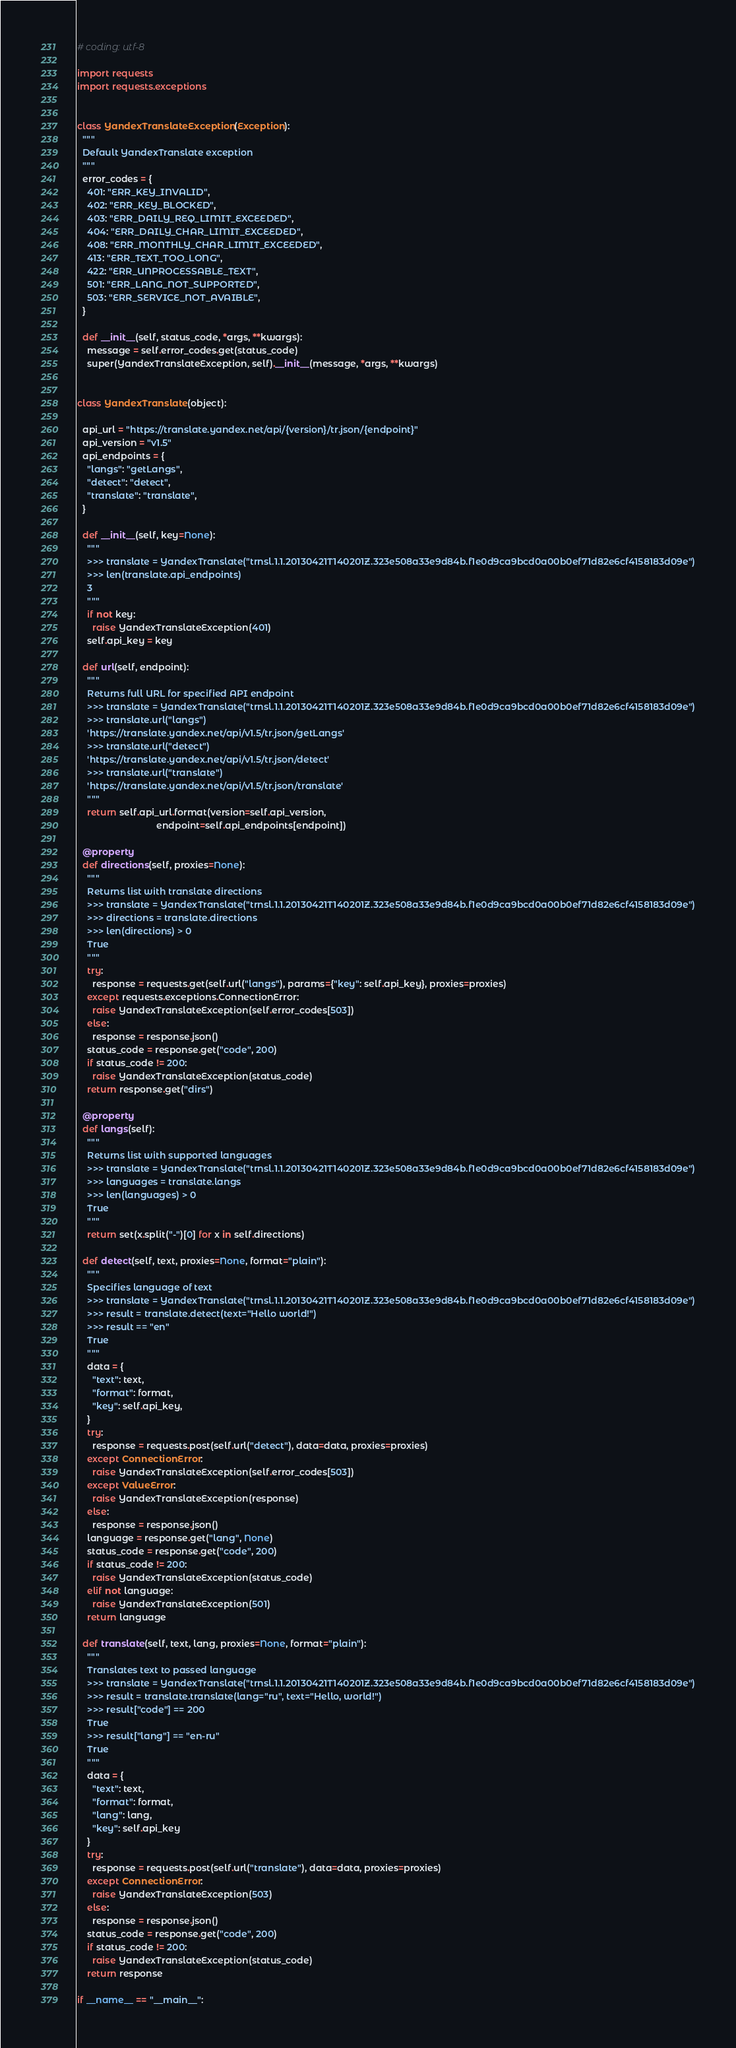<code> <loc_0><loc_0><loc_500><loc_500><_Python_># coding: utf-8

import requests
import requests.exceptions


class YandexTranslateException(Exception):
  """
  Default YandexTranslate exception
  """
  error_codes = {
    401: "ERR_KEY_INVALID",
    402: "ERR_KEY_BLOCKED",
    403: "ERR_DAILY_REQ_LIMIT_EXCEEDED",
    404: "ERR_DAILY_CHAR_LIMIT_EXCEEDED",
    408: "ERR_MONTHLY_CHAR_LIMIT_EXCEEDED",
    413: "ERR_TEXT_TOO_LONG",
    422: "ERR_UNPROCESSABLE_TEXT",
    501: "ERR_LANG_NOT_SUPPORTED",
    503: "ERR_SERVICE_NOT_AVAIBLE",
  }

  def __init__(self, status_code, *args, **kwargs):
    message = self.error_codes.get(status_code)
    super(YandexTranslateException, self).__init__(message, *args, **kwargs)


class YandexTranslate(object):

  api_url = "https://translate.yandex.net/api/{version}/tr.json/{endpoint}"
  api_version = "v1.5"
  api_endpoints = {
    "langs": "getLangs",
    "detect": "detect",
    "translate": "translate",
  }

  def __init__(self, key=None):
    """
    >>> translate = YandexTranslate("trnsl.1.1.20130421T140201Z.323e508a33e9d84b.f1e0d9ca9bcd0a00b0ef71d82e6cf4158183d09e")
    >>> len(translate.api_endpoints)
    3
    """
    if not key:
      raise YandexTranslateException(401)
    self.api_key = key

  def url(self, endpoint):
    """
    Returns full URL for specified API endpoint
    >>> translate = YandexTranslate("trnsl.1.1.20130421T140201Z.323e508a33e9d84b.f1e0d9ca9bcd0a00b0ef71d82e6cf4158183d09e")
    >>> translate.url("langs")
    'https://translate.yandex.net/api/v1.5/tr.json/getLangs'
    >>> translate.url("detect")
    'https://translate.yandex.net/api/v1.5/tr.json/detect'
    >>> translate.url("translate")
    'https://translate.yandex.net/api/v1.5/tr.json/translate'
    """
    return self.api_url.format(version=self.api_version,
                               endpoint=self.api_endpoints[endpoint])

  @property
  def directions(self, proxies=None):
    """
    Returns list with translate directions
    >>> translate = YandexTranslate("trnsl.1.1.20130421T140201Z.323e508a33e9d84b.f1e0d9ca9bcd0a00b0ef71d82e6cf4158183d09e")
    >>> directions = translate.directions
    >>> len(directions) > 0
    True
    """
    try:
      response = requests.get(self.url("langs"), params={"key": self.api_key}, proxies=proxies)
    except requests.exceptions.ConnectionError:
      raise YandexTranslateException(self.error_codes[503])
    else:
      response = response.json()
    status_code = response.get("code", 200)
    if status_code != 200:
      raise YandexTranslateException(status_code)
    return response.get("dirs")

  @property
  def langs(self):
    """
    Returns list with supported languages
    >>> translate = YandexTranslate("trnsl.1.1.20130421T140201Z.323e508a33e9d84b.f1e0d9ca9bcd0a00b0ef71d82e6cf4158183d09e")
    >>> languages = translate.langs
    >>> len(languages) > 0
    True
    """
    return set(x.split("-")[0] for x in self.directions)

  def detect(self, text, proxies=None, format="plain"):
    """
    Specifies language of text
    >>> translate = YandexTranslate("trnsl.1.1.20130421T140201Z.323e508a33e9d84b.f1e0d9ca9bcd0a00b0ef71d82e6cf4158183d09e")
    >>> result = translate.detect(text="Hello world!")
    >>> result == "en"
    True
    """
    data = {
      "text": text,
      "format": format,
      "key": self.api_key,
    }
    try:
      response = requests.post(self.url("detect"), data=data, proxies=proxies)
    except ConnectionError:
      raise YandexTranslateException(self.error_codes[503])
    except ValueError:
      raise YandexTranslateException(response)
    else:
      response = response.json()
    language = response.get("lang", None)
    status_code = response.get("code", 200)
    if status_code != 200:
      raise YandexTranslateException(status_code)
    elif not language:
      raise YandexTranslateException(501)
    return language

  def translate(self, text, lang, proxies=None, format="plain"):
    """
    Translates text to passed language
    >>> translate = YandexTranslate("trnsl.1.1.20130421T140201Z.323e508a33e9d84b.f1e0d9ca9bcd0a00b0ef71d82e6cf4158183d09e")
    >>> result = translate.translate(lang="ru", text="Hello, world!")
    >>> result["code"] == 200
    True
    >>> result["lang"] == "en-ru"
    True
    """
    data = {
      "text": text,
      "format": format,
      "lang": lang,
      "key": self.api_key
    }
    try:
      response = requests.post(self.url("translate"), data=data, proxies=proxies)
    except ConnectionError:
      raise YandexTranslateException(503)
    else:
      response = response.json()
    status_code = response.get("code", 200)
    if status_code != 200:
      raise YandexTranslateException(status_code)
    return response

if __name__ == "__main__":</code> 